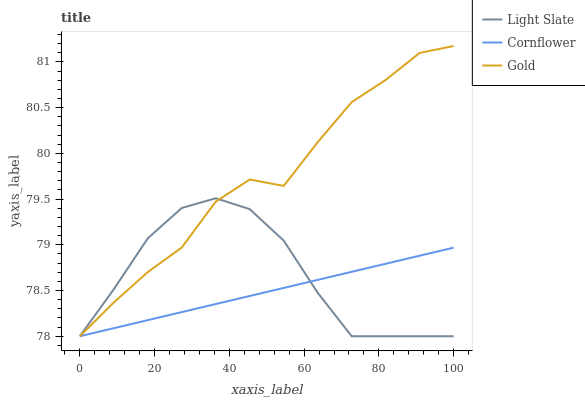Does Gold have the minimum area under the curve?
Answer yes or no. No. Does Cornflower have the maximum area under the curve?
Answer yes or no. No. Is Gold the smoothest?
Answer yes or no. No. Is Cornflower the roughest?
Answer yes or no. No. Does Cornflower have the highest value?
Answer yes or no. No. 